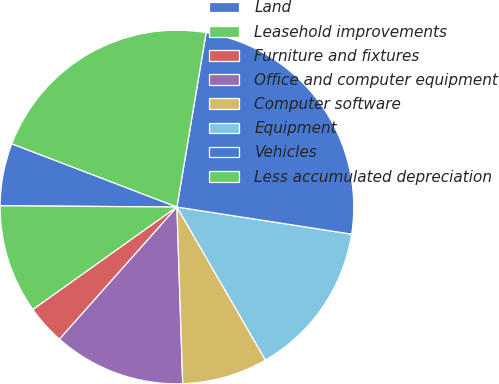Convert chart to OTSL. <chart><loc_0><loc_0><loc_500><loc_500><pie_chart><fcel>Land<fcel>Leasehold improvements<fcel>Furniture and fixtures<fcel>Office and computer equipment<fcel>Computer software<fcel>Equipment<fcel>Vehicles<fcel>Less accumulated depreciation<nl><fcel>5.71%<fcel>9.96%<fcel>3.59%<fcel>12.08%<fcel>7.83%<fcel>14.2%<fcel>24.81%<fcel>21.82%<nl></chart> 